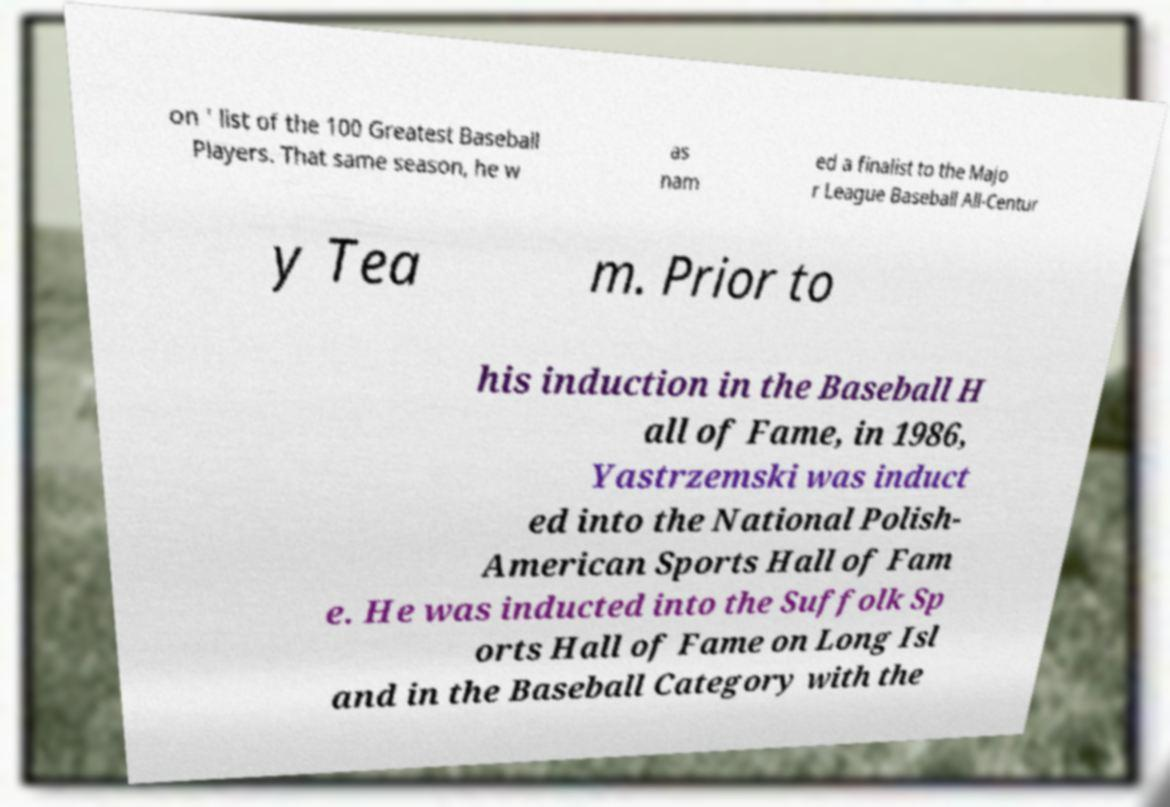Can you read and provide the text displayed in the image?This photo seems to have some interesting text. Can you extract and type it out for me? on ' list of the 100 Greatest Baseball Players. That same season, he w as nam ed a finalist to the Majo r League Baseball All-Centur y Tea m. Prior to his induction in the Baseball H all of Fame, in 1986, Yastrzemski was induct ed into the National Polish- American Sports Hall of Fam e. He was inducted into the Suffolk Sp orts Hall of Fame on Long Isl and in the Baseball Category with the 